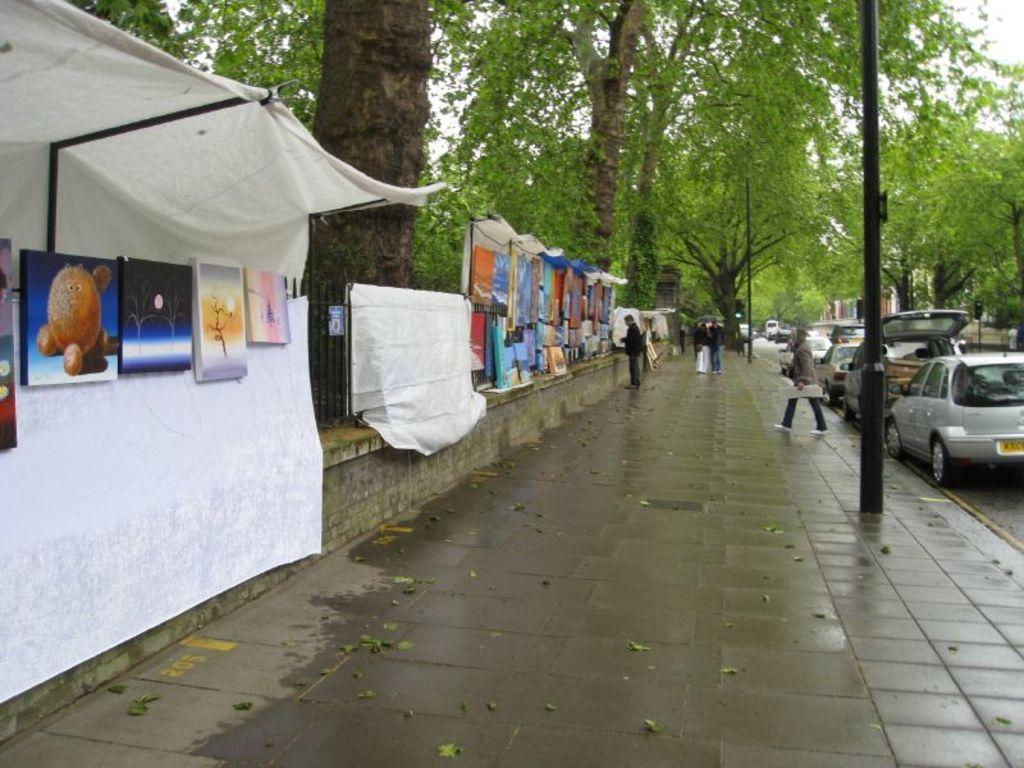Can you describe this image briefly? In the given image i can see a frames,clothes,people,vehicles and trees. 